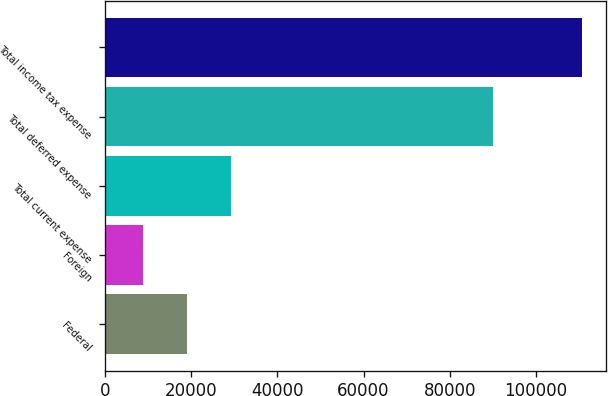Convert chart. <chart><loc_0><loc_0><loc_500><loc_500><bar_chart><fcel>Federal<fcel>Foreign<fcel>Total current expense<fcel>Total deferred expense<fcel>Total income tax expense<nl><fcel>19084.7<fcel>8910<fcel>29259.4<fcel>90059<fcel>110657<nl></chart> 